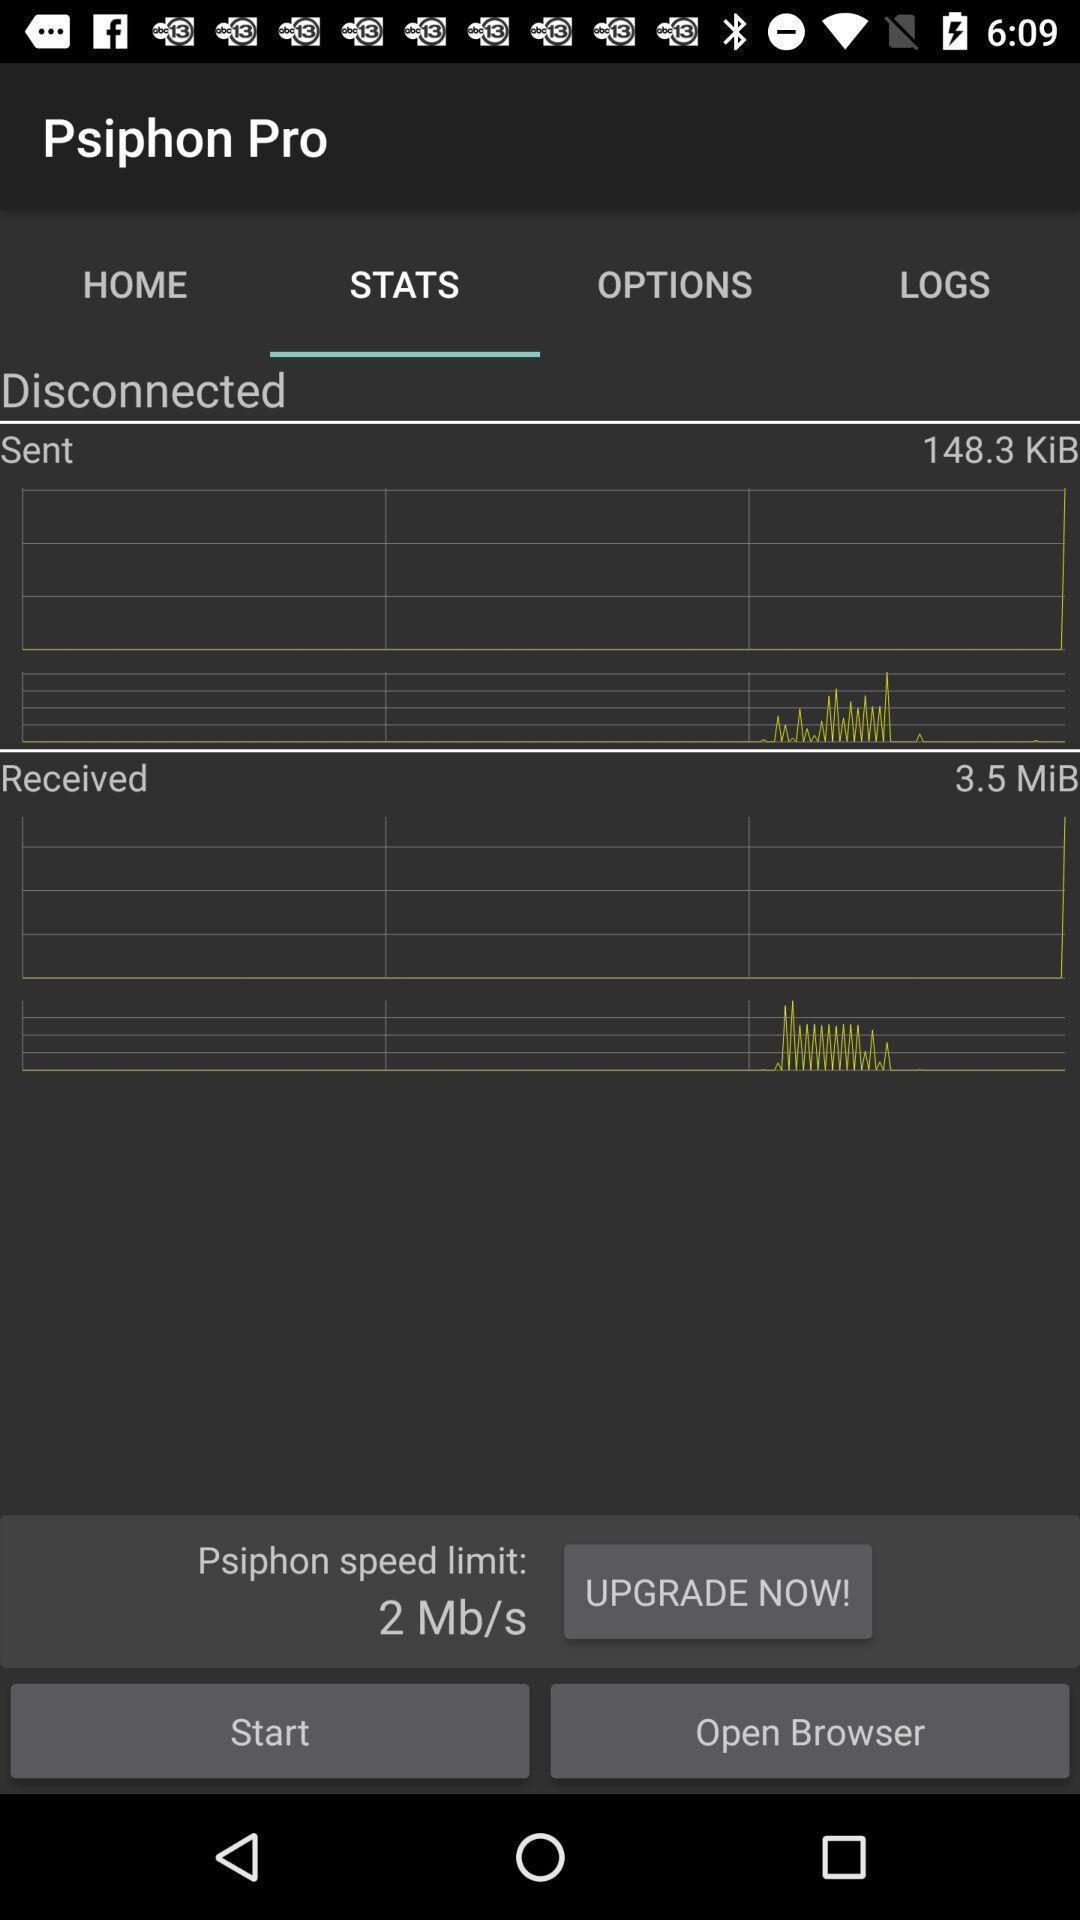What details can you identify in this image? Screen displaying the page of a social media app. 